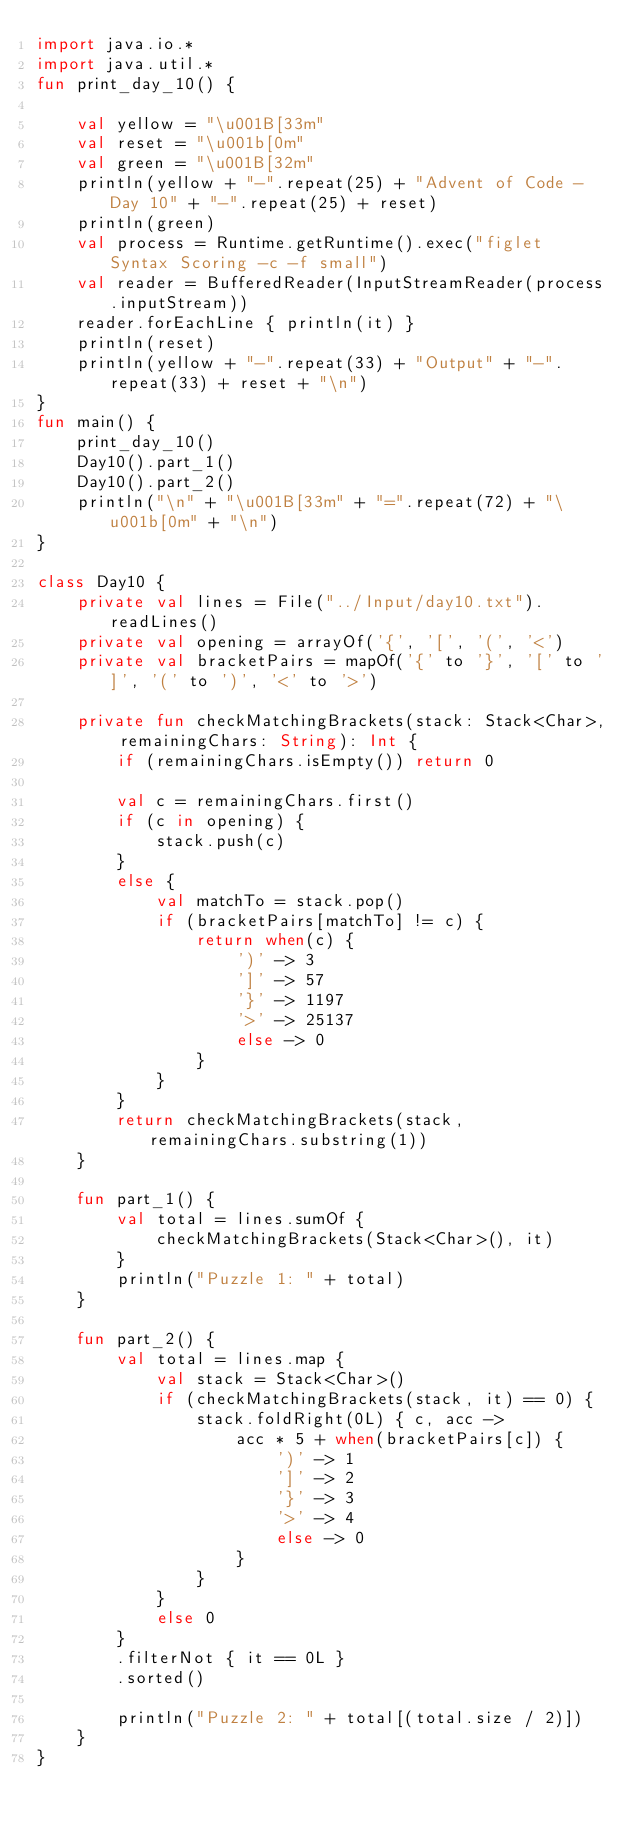Convert code to text. <code><loc_0><loc_0><loc_500><loc_500><_Kotlin_>import java.io.*
import java.util.*
fun print_day_10() {
    
    val yellow = "\u001B[33m"
    val reset = "\u001b[0m"
    val green = "\u001B[32m"
    println(yellow + "-".repeat(25) + "Advent of Code - Day 10" + "-".repeat(25) + reset)
    println(green)
    val process = Runtime.getRuntime().exec("figlet Syntax Scoring -c -f small")
    val reader = BufferedReader(InputStreamReader(process.inputStream))
    reader.forEachLine { println(it) }
    println(reset)
    println(yellow + "-".repeat(33) + "Output" + "-".repeat(33) + reset + "\n")
}
fun main() {
    print_day_10()
    Day10().part_1()
    Day10().part_2()
    println("\n" + "\u001B[33m" + "=".repeat(72) + "\u001b[0m" + "\n")
}

class Day10 {
    private val lines = File("../Input/day10.txt").readLines()
    private val opening = arrayOf('{', '[', '(', '<')
    private val bracketPairs = mapOf('{' to '}', '[' to ']', '(' to ')', '<' to '>')

    private fun checkMatchingBrackets(stack: Stack<Char>, remainingChars: String): Int {
        if (remainingChars.isEmpty()) return 0

        val c = remainingChars.first()
        if (c in opening) {
            stack.push(c)
        }
        else {
            val matchTo = stack.pop()
            if (bracketPairs[matchTo] != c) {
                return when(c) {
                    ')' -> 3
                    ']' -> 57
                    '}' -> 1197
                    '>' -> 25137
                    else -> 0
                }
            }
        }
        return checkMatchingBrackets(stack, remainingChars.substring(1))
    }

    fun part_1() {
        val total = lines.sumOf {
            checkMatchingBrackets(Stack<Char>(), it)
        }
        println("Puzzle 1: " + total)
    }

    fun part_2() {
        val total = lines.map {
            val stack = Stack<Char>()
            if (checkMatchingBrackets(stack, it) == 0) {
                stack.foldRight(0L) { c, acc ->
                    acc * 5 + when(bracketPairs[c]) {
                        ')' -> 1
                        ']' -> 2
                        '}' -> 3
                        '>' -> 4
                        else -> 0
                    }
                }
            }
            else 0
        }
        .filterNot { it == 0L }
        .sorted()

        println("Puzzle 2: " + total[(total.size / 2)])
    }
}</code> 